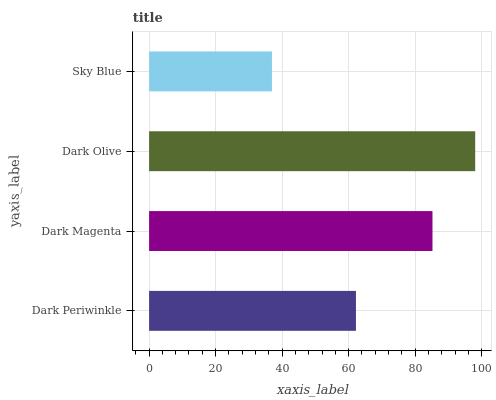Is Sky Blue the minimum?
Answer yes or no. Yes. Is Dark Olive the maximum?
Answer yes or no. Yes. Is Dark Magenta the minimum?
Answer yes or no. No. Is Dark Magenta the maximum?
Answer yes or no. No. Is Dark Magenta greater than Dark Periwinkle?
Answer yes or no. Yes. Is Dark Periwinkle less than Dark Magenta?
Answer yes or no. Yes. Is Dark Periwinkle greater than Dark Magenta?
Answer yes or no. No. Is Dark Magenta less than Dark Periwinkle?
Answer yes or no. No. Is Dark Magenta the high median?
Answer yes or no. Yes. Is Dark Periwinkle the low median?
Answer yes or no. Yes. Is Dark Olive the high median?
Answer yes or no. No. Is Dark Magenta the low median?
Answer yes or no. No. 